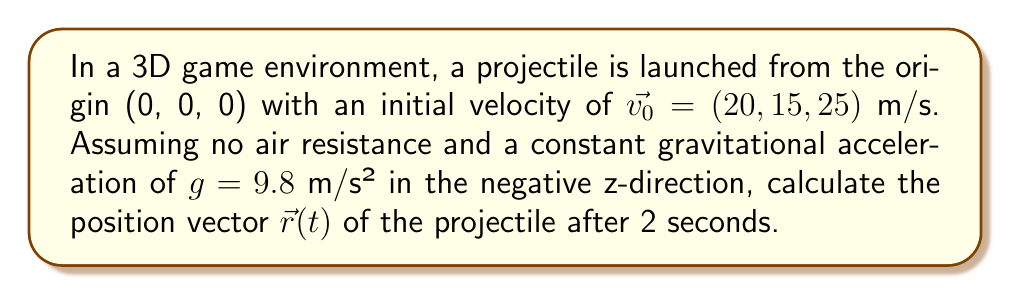Provide a solution to this math problem. To solve this problem, we'll use the equations of motion for a projectile in 3D space:

1) The position vector $\vec{r}(t)$ is given by:
   $$\vec{r}(t) = \vec{r_0} + \vec{v_0}t + \frac{1}{2}\vec{a}t^2$$

2) Where:
   - $\vec{r_0}$ is the initial position (0, 0, 0)
   - $\vec{v_0}$ is the initial velocity (20, 15, 25) m/s
   - $\vec{a}$ is the acceleration due to gravity (0, 0, -9.8) m/s²
   - $t$ is the time in seconds (2 s)

3) Let's break it down into components:
   $$x(t) = x_0 + v_{0x}t + \frac{1}{2}a_xt^2$$
   $$y(t) = y_0 + v_{0y}t + \frac{1}{2}a_yt^2$$
   $$z(t) = z_0 + v_{0z}t + \frac{1}{2}a_zt^2$$

4) Substituting the values:
   $$x(2) = 0 + 20 \cdot 2 + \frac{1}{2} \cdot 0 \cdot 2^2 = 40$$
   $$y(2) = 0 + 15 \cdot 2 + \frac{1}{2} \cdot 0 \cdot 2^2 = 30$$
   $$z(2) = 0 + 25 \cdot 2 + \frac{1}{2} \cdot (-9.8) \cdot 2^2 = 30.4$$

5) Therefore, the position vector after 2 seconds is:
   $$\vec{r}(2) = (40, 30, 30.4)$$
Answer: $(40, 30, 30.4)$ m 